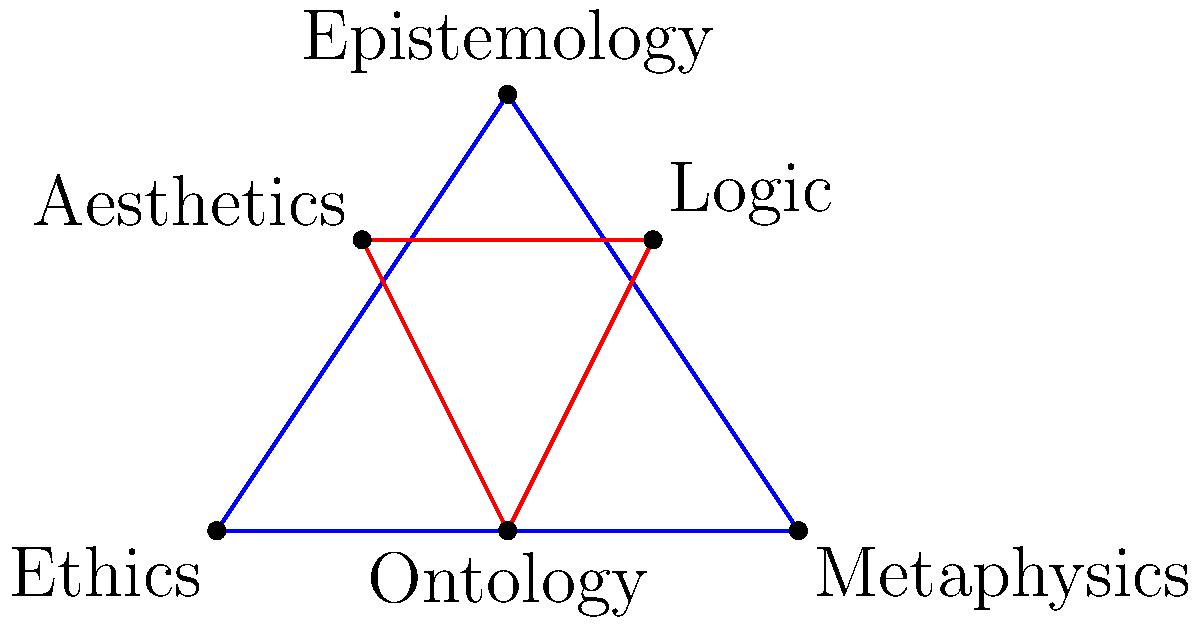In the diagram, two triangles are formed by connecting philosophical concepts. Triangle ABC represents the core branches of philosophy, while triangle DEF represents sub-branches. Given that the side lengths of triangle ABC are proportional to the importance of each branch in Western philosophy, and assuming that triangle DEF is congruent to triangle ABC, which criterion of triangle congruence would most effectively prove their congruence? To determine the most effective criterion for proving congruence between triangles ABC and DEF, we need to analyze the information given and the properties of the triangles:

1. Triangle ABC represents core branches of philosophy: Ethics (A), Metaphysics (B), and Epistemology (C).
2. Triangle DEF represents sub-branches: Aesthetics (D), Logic (E), and Ontology (F).
3. The side lengths of triangle ABC are proportional to the importance of each branch in Western philosophy.
4. We are told that triangle DEF is congruent to triangle ABC.

Given this information, we can consider the main criteria for triangle congruence:

a) Side-Side-Side (SSS): We don't have explicit information about all side lengths.
b) Angle-Side-Angle (ASA): We don't have information about angles.
c) Side-Angle-Side (SAS): We don't have information about angles.
d) Angle-Angle-Side (AAS): We don't have information about angles.

However, there's a crucial piece of information: the side lengths of triangle ABC are proportional to the importance of each branch. This suggests that if we can establish that the corresponding sides of triangle DEF maintain the same proportions, we can prove congruence.

The most effective criterion in this case would be the Side-Side-Side (SSS) congruence theorem. If we can show that all three sides of triangle DEF are proportional to the corresponding sides of triangle ABC, we can prove congruence without needing to know specific angle measurements.

This approach aligns well with the philosophical nature of the question, as it focuses on the relative importance (represented by side lengths) of different philosophical concepts rather than specific angular relationships between them.
Answer: Side-Side-Side (SSS) congruence theorem 